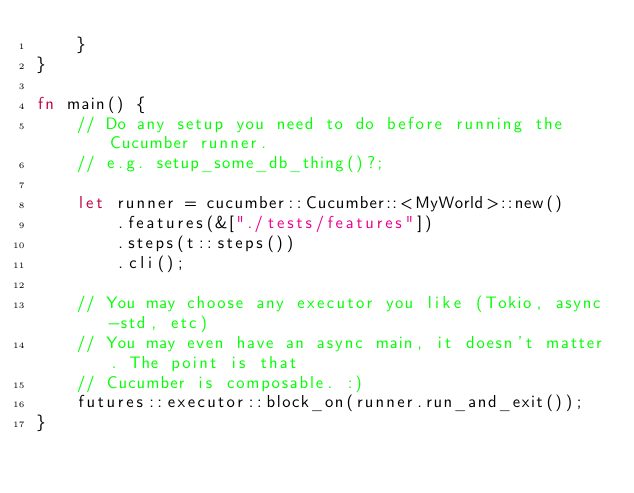Convert code to text. <code><loc_0><loc_0><loc_500><loc_500><_Rust_>    }
}

fn main() {
    // Do any setup you need to do before running the Cucumber runner.
    // e.g. setup_some_db_thing()?;

    let runner = cucumber::Cucumber::<MyWorld>::new()
        .features(&["./tests/features"])
        .steps(t::steps())
        .cli();

    // You may choose any executor you like (Tokio, async-std, etc)
    // You may even have an async main, it doesn't matter. The point is that
    // Cucumber is composable. :)
    futures::executor::block_on(runner.run_and_exit());
}
</code> 